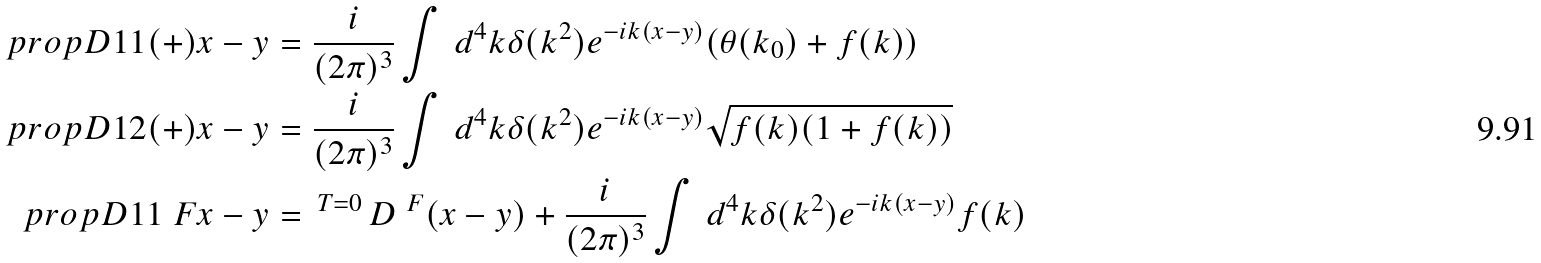<formula> <loc_0><loc_0><loc_500><loc_500>\ p r o p D { 1 1 } { ( + ) } { x - y } & = \frac { i } { ( 2 \pi ) ^ { 3 } } \int \, d ^ { 4 } k \delta ( k ^ { 2 } ) e ^ { - i k ( x - y ) } ( \theta ( k _ { 0 } ) + f ( k ) ) \\ \ p r o p D { 1 2 } { ( + ) } { x - y } & = \frac { i } { ( 2 \pi ) ^ { 3 } } \int \, d ^ { 4 } k \delta ( k ^ { 2 } ) e ^ { - i k ( x - y ) } \sqrt { f ( k ) ( 1 + f ( k ) ) } \\ \ p r o p D { 1 1 } { \ F } { x - y } & = \, { ^ { T = 0 } } \, D ^ { \ F } ( x - y ) + \frac { i } { ( 2 \pi ) ^ { 3 } } \int \, d ^ { 4 } k \delta ( k ^ { 2 } ) e ^ { - i k ( x - y ) } f ( k ) \\</formula> 